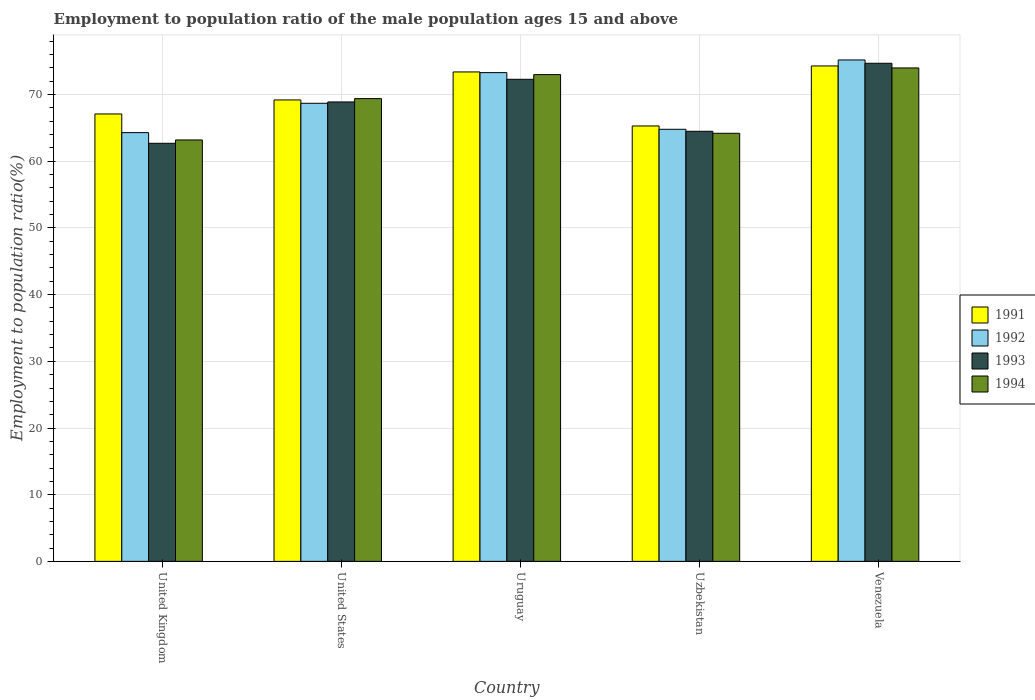How many different coloured bars are there?
Your answer should be compact. 4. How many groups of bars are there?
Your answer should be very brief. 5. Are the number of bars on each tick of the X-axis equal?
Your answer should be very brief. Yes. How many bars are there on the 5th tick from the right?
Your answer should be compact. 4. In how many cases, is the number of bars for a given country not equal to the number of legend labels?
Your response must be concise. 0. What is the employment to population ratio in 1991 in Venezuela?
Provide a short and direct response. 74.3. Across all countries, what is the maximum employment to population ratio in 1993?
Make the answer very short. 74.7. Across all countries, what is the minimum employment to population ratio in 1992?
Provide a succinct answer. 64.3. In which country was the employment to population ratio in 1991 maximum?
Provide a short and direct response. Venezuela. What is the total employment to population ratio in 1992 in the graph?
Offer a very short reply. 346.3. What is the difference between the employment to population ratio in 1993 in Uruguay and that in Uzbekistan?
Provide a short and direct response. 7.8. What is the difference between the employment to population ratio in 1991 in Uruguay and the employment to population ratio in 1994 in Uzbekistan?
Ensure brevity in your answer.  9.2. What is the average employment to population ratio in 1992 per country?
Your answer should be compact. 69.26. What is the difference between the employment to population ratio of/in 1994 and employment to population ratio of/in 1991 in Venezuela?
Ensure brevity in your answer.  -0.3. What is the ratio of the employment to population ratio in 1992 in Uzbekistan to that in Venezuela?
Offer a terse response. 0.86. Is the employment to population ratio in 1991 in United Kingdom less than that in Uruguay?
Give a very brief answer. Yes. Is the difference between the employment to population ratio in 1994 in United Kingdom and Uruguay greater than the difference between the employment to population ratio in 1991 in United Kingdom and Uruguay?
Give a very brief answer. No. What is the difference between the highest and the second highest employment to population ratio in 1992?
Your answer should be very brief. -1.9. What is the difference between the highest and the lowest employment to population ratio in 1991?
Make the answer very short. 9. How many bars are there?
Ensure brevity in your answer.  20. Are all the bars in the graph horizontal?
Offer a very short reply. No. Are the values on the major ticks of Y-axis written in scientific E-notation?
Your answer should be compact. No. Does the graph contain grids?
Give a very brief answer. Yes. What is the title of the graph?
Make the answer very short. Employment to population ratio of the male population ages 15 and above. Does "2003" appear as one of the legend labels in the graph?
Provide a short and direct response. No. What is the label or title of the Y-axis?
Make the answer very short. Employment to population ratio(%). What is the Employment to population ratio(%) in 1991 in United Kingdom?
Your response must be concise. 67.1. What is the Employment to population ratio(%) of 1992 in United Kingdom?
Ensure brevity in your answer.  64.3. What is the Employment to population ratio(%) in 1993 in United Kingdom?
Your response must be concise. 62.7. What is the Employment to population ratio(%) of 1994 in United Kingdom?
Provide a succinct answer. 63.2. What is the Employment to population ratio(%) of 1991 in United States?
Your response must be concise. 69.2. What is the Employment to population ratio(%) in 1992 in United States?
Your response must be concise. 68.7. What is the Employment to population ratio(%) of 1993 in United States?
Offer a very short reply. 68.9. What is the Employment to population ratio(%) of 1994 in United States?
Ensure brevity in your answer.  69.4. What is the Employment to population ratio(%) in 1991 in Uruguay?
Give a very brief answer. 73.4. What is the Employment to population ratio(%) in 1992 in Uruguay?
Ensure brevity in your answer.  73.3. What is the Employment to population ratio(%) in 1993 in Uruguay?
Make the answer very short. 72.3. What is the Employment to population ratio(%) in 1991 in Uzbekistan?
Make the answer very short. 65.3. What is the Employment to population ratio(%) of 1992 in Uzbekistan?
Keep it short and to the point. 64.8. What is the Employment to population ratio(%) of 1993 in Uzbekistan?
Provide a succinct answer. 64.5. What is the Employment to population ratio(%) of 1994 in Uzbekistan?
Keep it short and to the point. 64.2. What is the Employment to population ratio(%) of 1991 in Venezuela?
Offer a terse response. 74.3. What is the Employment to population ratio(%) in 1992 in Venezuela?
Your answer should be compact. 75.2. What is the Employment to population ratio(%) of 1993 in Venezuela?
Provide a short and direct response. 74.7. What is the Employment to population ratio(%) in 1994 in Venezuela?
Make the answer very short. 74. Across all countries, what is the maximum Employment to population ratio(%) in 1991?
Provide a short and direct response. 74.3. Across all countries, what is the maximum Employment to population ratio(%) of 1992?
Make the answer very short. 75.2. Across all countries, what is the maximum Employment to population ratio(%) of 1993?
Ensure brevity in your answer.  74.7. Across all countries, what is the minimum Employment to population ratio(%) of 1991?
Your answer should be compact. 65.3. Across all countries, what is the minimum Employment to population ratio(%) of 1992?
Your answer should be very brief. 64.3. Across all countries, what is the minimum Employment to population ratio(%) in 1993?
Give a very brief answer. 62.7. Across all countries, what is the minimum Employment to population ratio(%) of 1994?
Offer a very short reply. 63.2. What is the total Employment to population ratio(%) of 1991 in the graph?
Offer a terse response. 349.3. What is the total Employment to population ratio(%) in 1992 in the graph?
Your response must be concise. 346.3. What is the total Employment to population ratio(%) in 1993 in the graph?
Make the answer very short. 343.1. What is the total Employment to population ratio(%) of 1994 in the graph?
Your answer should be very brief. 343.8. What is the difference between the Employment to population ratio(%) of 1992 in United Kingdom and that in United States?
Make the answer very short. -4.4. What is the difference between the Employment to population ratio(%) of 1991 in United Kingdom and that in Uruguay?
Give a very brief answer. -6.3. What is the difference between the Employment to population ratio(%) in 1991 in United Kingdom and that in Uzbekistan?
Ensure brevity in your answer.  1.8. What is the difference between the Employment to population ratio(%) of 1993 in United Kingdom and that in Uzbekistan?
Provide a succinct answer. -1.8. What is the difference between the Employment to population ratio(%) of 1991 in United Kingdom and that in Venezuela?
Your answer should be compact. -7.2. What is the difference between the Employment to population ratio(%) of 1991 in United States and that in Uruguay?
Provide a succinct answer. -4.2. What is the difference between the Employment to population ratio(%) of 1993 in United States and that in Uruguay?
Offer a terse response. -3.4. What is the difference between the Employment to population ratio(%) of 1994 in United States and that in Uruguay?
Provide a short and direct response. -3.6. What is the difference between the Employment to population ratio(%) of 1992 in United States and that in Uzbekistan?
Ensure brevity in your answer.  3.9. What is the difference between the Employment to population ratio(%) of 1993 in United States and that in Uzbekistan?
Offer a terse response. 4.4. What is the difference between the Employment to population ratio(%) of 1991 in United States and that in Venezuela?
Offer a terse response. -5.1. What is the difference between the Employment to population ratio(%) of 1993 in United States and that in Venezuela?
Provide a succinct answer. -5.8. What is the difference between the Employment to population ratio(%) of 1994 in United States and that in Venezuela?
Give a very brief answer. -4.6. What is the difference between the Employment to population ratio(%) of 1991 in Uruguay and that in Uzbekistan?
Make the answer very short. 8.1. What is the difference between the Employment to population ratio(%) of 1992 in Uruguay and that in Uzbekistan?
Your answer should be very brief. 8.5. What is the difference between the Employment to population ratio(%) of 1991 in Uruguay and that in Venezuela?
Ensure brevity in your answer.  -0.9. What is the difference between the Employment to population ratio(%) of 1992 in Uruguay and that in Venezuela?
Provide a succinct answer. -1.9. What is the difference between the Employment to population ratio(%) of 1993 in Uruguay and that in Venezuela?
Your response must be concise. -2.4. What is the difference between the Employment to population ratio(%) of 1992 in Uzbekistan and that in Venezuela?
Ensure brevity in your answer.  -10.4. What is the difference between the Employment to population ratio(%) in 1993 in Uzbekistan and that in Venezuela?
Give a very brief answer. -10.2. What is the difference between the Employment to population ratio(%) in 1994 in Uzbekistan and that in Venezuela?
Offer a terse response. -9.8. What is the difference between the Employment to population ratio(%) in 1991 in United Kingdom and the Employment to population ratio(%) in 1992 in United States?
Your answer should be compact. -1.6. What is the difference between the Employment to population ratio(%) of 1991 in United Kingdom and the Employment to population ratio(%) of 1993 in United States?
Offer a terse response. -1.8. What is the difference between the Employment to population ratio(%) of 1992 in United Kingdom and the Employment to population ratio(%) of 1993 in United States?
Provide a succinct answer. -4.6. What is the difference between the Employment to population ratio(%) of 1993 in United Kingdom and the Employment to population ratio(%) of 1994 in United States?
Your answer should be compact. -6.7. What is the difference between the Employment to population ratio(%) in 1991 in United Kingdom and the Employment to population ratio(%) in 1994 in Uruguay?
Ensure brevity in your answer.  -5.9. What is the difference between the Employment to population ratio(%) of 1992 in United Kingdom and the Employment to population ratio(%) of 1993 in Uruguay?
Provide a succinct answer. -8. What is the difference between the Employment to population ratio(%) of 1991 in United Kingdom and the Employment to population ratio(%) of 1992 in Uzbekistan?
Provide a short and direct response. 2.3. What is the difference between the Employment to population ratio(%) of 1991 in United Kingdom and the Employment to population ratio(%) of 1993 in Uzbekistan?
Your answer should be compact. 2.6. What is the difference between the Employment to population ratio(%) in 1992 in United Kingdom and the Employment to population ratio(%) in 1994 in Uzbekistan?
Your response must be concise. 0.1. What is the difference between the Employment to population ratio(%) of 1992 in United Kingdom and the Employment to population ratio(%) of 1993 in Venezuela?
Your response must be concise. -10.4. What is the difference between the Employment to population ratio(%) of 1991 in United States and the Employment to population ratio(%) of 1994 in Uruguay?
Provide a short and direct response. -3.8. What is the difference between the Employment to population ratio(%) of 1992 in United States and the Employment to population ratio(%) of 1993 in Uruguay?
Give a very brief answer. -3.6. What is the difference between the Employment to population ratio(%) of 1992 in United States and the Employment to population ratio(%) of 1994 in Uruguay?
Ensure brevity in your answer.  -4.3. What is the difference between the Employment to population ratio(%) in 1993 in United States and the Employment to population ratio(%) in 1994 in Uruguay?
Ensure brevity in your answer.  -4.1. What is the difference between the Employment to population ratio(%) of 1991 in United States and the Employment to population ratio(%) of 1992 in Uzbekistan?
Keep it short and to the point. 4.4. What is the difference between the Employment to population ratio(%) in 1991 in United States and the Employment to population ratio(%) in 1994 in Uzbekistan?
Ensure brevity in your answer.  5. What is the difference between the Employment to population ratio(%) in 1993 in United States and the Employment to population ratio(%) in 1994 in Uzbekistan?
Make the answer very short. 4.7. What is the difference between the Employment to population ratio(%) in 1991 in United States and the Employment to population ratio(%) in 1993 in Venezuela?
Keep it short and to the point. -5.5. What is the difference between the Employment to population ratio(%) of 1991 in United States and the Employment to population ratio(%) of 1994 in Venezuela?
Your answer should be compact. -4.8. What is the difference between the Employment to population ratio(%) in 1992 in United States and the Employment to population ratio(%) in 1994 in Venezuela?
Offer a terse response. -5.3. What is the difference between the Employment to population ratio(%) of 1991 in Uruguay and the Employment to population ratio(%) of 1992 in Uzbekistan?
Offer a very short reply. 8.6. What is the difference between the Employment to population ratio(%) of 1991 in Uruguay and the Employment to population ratio(%) of 1993 in Uzbekistan?
Offer a very short reply. 8.9. What is the difference between the Employment to population ratio(%) in 1991 in Uruguay and the Employment to population ratio(%) in 1994 in Uzbekistan?
Offer a terse response. 9.2. What is the difference between the Employment to population ratio(%) in 1993 in Uruguay and the Employment to population ratio(%) in 1994 in Uzbekistan?
Offer a terse response. 8.1. What is the difference between the Employment to population ratio(%) in 1992 in Uruguay and the Employment to population ratio(%) in 1994 in Venezuela?
Offer a very short reply. -0.7. What is the difference between the Employment to population ratio(%) of 1991 in Uzbekistan and the Employment to population ratio(%) of 1992 in Venezuela?
Make the answer very short. -9.9. What is the difference between the Employment to population ratio(%) in 1991 in Uzbekistan and the Employment to population ratio(%) in 1994 in Venezuela?
Your answer should be compact. -8.7. What is the difference between the Employment to population ratio(%) of 1992 in Uzbekistan and the Employment to population ratio(%) of 1993 in Venezuela?
Give a very brief answer. -9.9. What is the average Employment to population ratio(%) in 1991 per country?
Your answer should be very brief. 69.86. What is the average Employment to population ratio(%) of 1992 per country?
Give a very brief answer. 69.26. What is the average Employment to population ratio(%) of 1993 per country?
Provide a short and direct response. 68.62. What is the average Employment to population ratio(%) of 1994 per country?
Keep it short and to the point. 68.76. What is the difference between the Employment to population ratio(%) in 1991 and Employment to population ratio(%) in 1992 in United Kingdom?
Your answer should be compact. 2.8. What is the difference between the Employment to population ratio(%) in 1991 and Employment to population ratio(%) in 1994 in United Kingdom?
Give a very brief answer. 3.9. What is the difference between the Employment to population ratio(%) in 1992 and Employment to population ratio(%) in 1994 in United Kingdom?
Keep it short and to the point. 1.1. What is the difference between the Employment to population ratio(%) of 1993 and Employment to population ratio(%) of 1994 in United Kingdom?
Provide a succinct answer. -0.5. What is the difference between the Employment to population ratio(%) in 1991 and Employment to population ratio(%) in 1994 in United States?
Make the answer very short. -0.2. What is the difference between the Employment to population ratio(%) in 1993 and Employment to population ratio(%) in 1994 in United States?
Provide a short and direct response. -0.5. What is the difference between the Employment to population ratio(%) in 1991 and Employment to population ratio(%) in 1994 in Uruguay?
Offer a terse response. 0.4. What is the difference between the Employment to population ratio(%) of 1993 and Employment to population ratio(%) of 1994 in Uruguay?
Offer a terse response. -0.7. What is the difference between the Employment to population ratio(%) of 1991 and Employment to population ratio(%) of 1993 in Uzbekistan?
Provide a short and direct response. 0.8. What is the difference between the Employment to population ratio(%) of 1991 and Employment to population ratio(%) of 1994 in Uzbekistan?
Ensure brevity in your answer.  1.1. What is the difference between the Employment to population ratio(%) in 1992 and Employment to population ratio(%) in 1993 in Uzbekistan?
Provide a succinct answer. 0.3. What is the difference between the Employment to population ratio(%) in 1992 and Employment to population ratio(%) in 1994 in Uzbekistan?
Ensure brevity in your answer.  0.6. What is the difference between the Employment to population ratio(%) in 1991 and Employment to population ratio(%) in 1993 in Venezuela?
Ensure brevity in your answer.  -0.4. What is the difference between the Employment to population ratio(%) in 1992 and Employment to population ratio(%) in 1993 in Venezuela?
Offer a very short reply. 0.5. What is the difference between the Employment to population ratio(%) in 1993 and Employment to population ratio(%) in 1994 in Venezuela?
Provide a short and direct response. 0.7. What is the ratio of the Employment to population ratio(%) of 1991 in United Kingdom to that in United States?
Offer a terse response. 0.97. What is the ratio of the Employment to population ratio(%) of 1992 in United Kingdom to that in United States?
Your response must be concise. 0.94. What is the ratio of the Employment to population ratio(%) of 1993 in United Kingdom to that in United States?
Keep it short and to the point. 0.91. What is the ratio of the Employment to population ratio(%) of 1994 in United Kingdom to that in United States?
Provide a short and direct response. 0.91. What is the ratio of the Employment to population ratio(%) of 1991 in United Kingdom to that in Uruguay?
Offer a terse response. 0.91. What is the ratio of the Employment to population ratio(%) of 1992 in United Kingdom to that in Uruguay?
Your answer should be very brief. 0.88. What is the ratio of the Employment to population ratio(%) in 1993 in United Kingdom to that in Uruguay?
Your response must be concise. 0.87. What is the ratio of the Employment to population ratio(%) of 1994 in United Kingdom to that in Uruguay?
Ensure brevity in your answer.  0.87. What is the ratio of the Employment to population ratio(%) of 1991 in United Kingdom to that in Uzbekistan?
Offer a terse response. 1.03. What is the ratio of the Employment to population ratio(%) in 1993 in United Kingdom to that in Uzbekistan?
Give a very brief answer. 0.97. What is the ratio of the Employment to population ratio(%) of 1994 in United Kingdom to that in Uzbekistan?
Make the answer very short. 0.98. What is the ratio of the Employment to population ratio(%) in 1991 in United Kingdom to that in Venezuela?
Provide a short and direct response. 0.9. What is the ratio of the Employment to population ratio(%) of 1992 in United Kingdom to that in Venezuela?
Keep it short and to the point. 0.86. What is the ratio of the Employment to population ratio(%) of 1993 in United Kingdom to that in Venezuela?
Give a very brief answer. 0.84. What is the ratio of the Employment to population ratio(%) of 1994 in United Kingdom to that in Venezuela?
Offer a terse response. 0.85. What is the ratio of the Employment to population ratio(%) of 1991 in United States to that in Uruguay?
Provide a succinct answer. 0.94. What is the ratio of the Employment to population ratio(%) in 1992 in United States to that in Uruguay?
Provide a succinct answer. 0.94. What is the ratio of the Employment to population ratio(%) of 1993 in United States to that in Uruguay?
Ensure brevity in your answer.  0.95. What is the ratio of the Employment to population ratio(%) in 1994 in United States to that in Uruguay?
Give a very brief answer. 0.95. What is the ratio of the Employment to population ratio(%) in 1991 in United States to that in Uzbekistan?
Keep it short and to the point. 1.06. What is the ratio of the Employment to population ratio(%) of 1992 in United States to that in Uzbekistan?
Offer a terse response. 1.06. What is the ratio of the Employment to population ratio(%) in 1993 in United States to that in Uzbekistan?
Offer a terse response. 1.07. What is the ratio of the Employment to population ratio(%) of 1994 in United States to that in Uzbekistan?
Make the answer very short. 1.08. What is the ratio of the Employment to population ratio(%) of 1991 in United States to that in Venezuela?
Ensure brevity in your answer.  0.93. What is the ratio of the Employment to population ratio(%) of 1992 in United States to that in Venezuela?
Offer a terse response. 0.91. What is the ratio of the Employment to population ratio(%) of 1993 in United States to that in Venezuela?
Provide a short and direct response. 0.92. What is the ratio of the Employment to population ratio(%) in 1994 in United States to that in Venezuela?
Offer a terse response. 0.94. What is the ratio of the Employment to population ratio(%) of 1991 in Uruguay to that in Uzbekistan?
Your answer should be compact. 1.12. What is the ratio of the Employment to population ratio(%) of 1992 in Uruguay to that in Uzbekistan?
Your response must be concise. 1.13. What is the ratio of the Employment to population ratio(%) in 1993 in Uruguay to that in Uzbekistan?
Ensure brevity in your answer.  1.12. What is the ratio of the Employment to population ratio(%) in 1994 in Uruguay to that in Uzbekistan?
Provide a short and direct response. 1.14. What is the ratio of the Employment to population ratio(%) of 1991 in Uruguay to that in Venezuela?
Provide a succinct answer. 0.99. What is the ratio of the Employment to population ratio(%) of 1992 in Uruguay to that in Venezuela?
Make the answer very short. 0.97. What is the ratio of the Employment to population ratio(%) of 1993 in Uruguay to that in Venezuela?
Offer a terse response. 0.97. What is the ratio of the Employment to population ratio(%) of 1994 in Uruguay to that in Venezuela?
Offer a terse response. 0.99. What is the ratio of the Employment to population ratio(%) in 1991 in Uzbekistan to that in Venezuela?
Offer a terse response. 0.88. What is the ratio of the Employment to population ratio(%) of 1992 in Uzbekistan to that in Venezuela?
Provide a short and direct response. 0.86. What is the ratio of the Employment to population ratio(%) in 1993 in Uzbekistan to that in Venezuela?
Your response must be concise. 0.86. What is the ratio of the Employment to population ratio(%) in 1994 in Uzbekistan to that in Venezuela?
Your answer should be compact. 0.87. What is the difference between the highest and the second highest Employment to population ratio(%) in 1991?
Your answer should be very brief. 0.9. What is the difference between the highest and the second highest Employment to population ratio(%) in 1994?
Provide a succinct answer. 1. What is the difference between the highest and the lowest Employment to population ratio(%) of 1991?
Your answer should be compact. 9. What is the difference between the highest and the lowest Employment to population ratio(%) in 1992?
Offer a terse response. 10.9. What is the difference between the highest and the lowest Employment to population ratio(%) in 1994?
Your response must be concise. 10.8. 